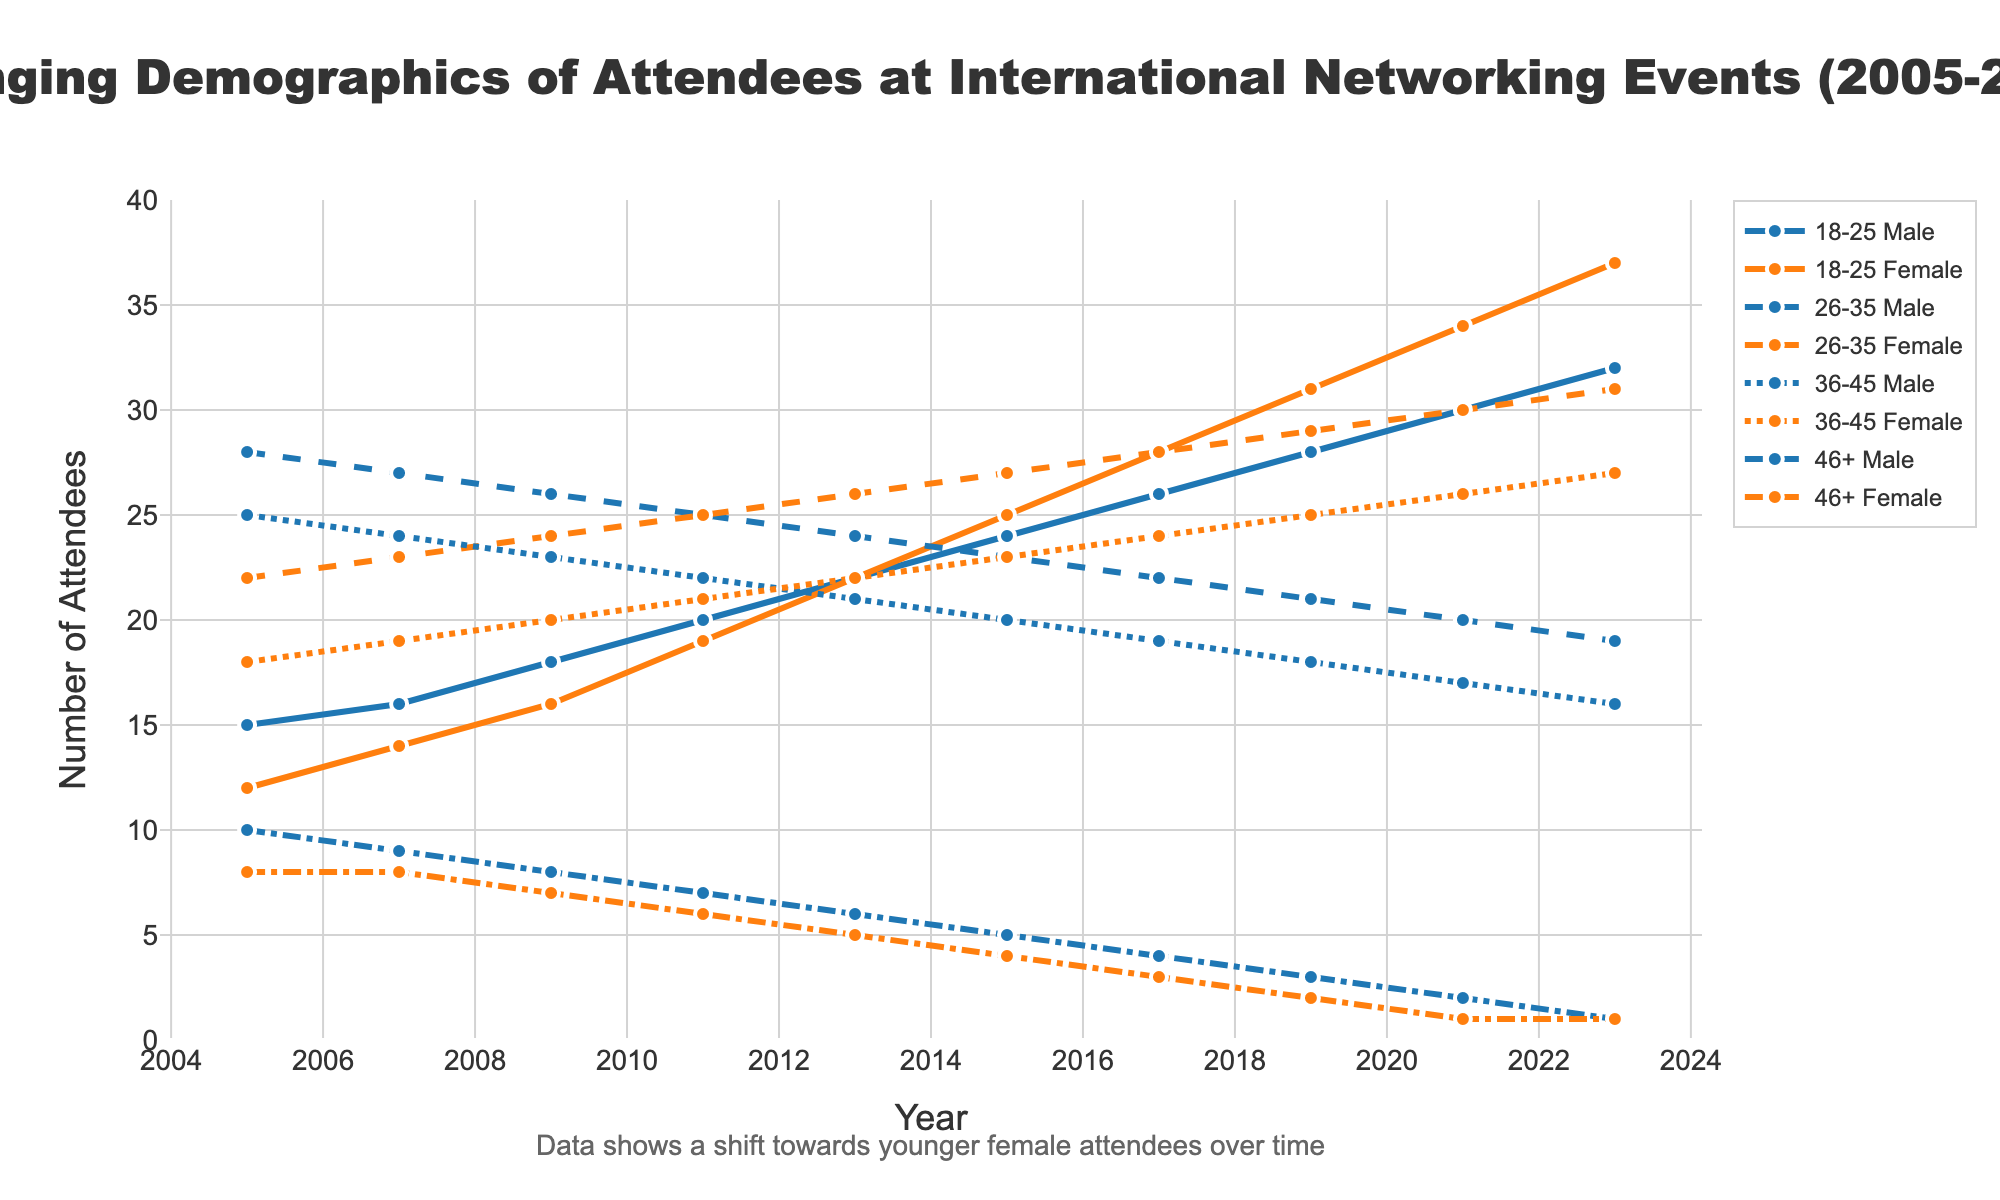Which age group had the greatest increase in female attendees from 2005 to 2023? To find this, compare the number of female attendees in each age group for 2023 with 2005. Calculate the increase for each group: (18-25): 37-12=25, (26-35): 31-22=9, (36-45): 27-18=9, (46+): 1-8=-7. The group 18-25 had the greatest increase.
Answer: 18-25 Between which two consecutive years did the number of 26-35 Male attendees see the largest decrease? Check the number of 26-35 Male attendees for each year and find the differences between consecutive years: (2005-2007): 27-28=-1, (2007-2009): 26-27=-1, (2009-2011): 25-26=-1, (2011-2013): 24-25=-1, (2013-2015): 23-24=-1, (2015-2017): 22-23=-1, (2017-2019): 21-22=-1, (2019-2021): 20-21=-1, (2021-2023): 19-20=-1. Each year shows a decrease of 1, thus any consecutive years can be mentioned.
Answer: 2005-2007 What is the total number of attendees in 2023? Sum the number of all attendees for 2023: 32 (18-25 Male) + 37 (18-25 Female) + 19 (26-35 Male) + 31 (26-35 Female) + 16 (36-45 Male) + 27 (36-45 Female) + 1 (46+ Male) + 1 (46+ Female) = 164.
Answer: 164 In which year did the representation of 36-45 females equal the representation of 36-45 males? Look at the dataset to find where the values for 36-45 females are equal to 36-45 males. In 2011, both 36-45 Male and 36-45 Female have 21 attendees.
Answer: 2011 By looking at the visual, which age group has the most evenly distributed gender representation in 2005? Check the visual lines for 2005; 18-25 males and females are close in number, indicated by the points for each gender being close together for the year 2005.
Answer: 18-25 How does the trend for 46+ Male and Female attendees change over the years? Observe the visual where lines representing 46+ Male and Female consistently decrease over the years, moving towards fewer attendees.
Answer: Decreasing What is the average number of 18-25 Female attendees from 2005 to 2023? Sum the 18-25 Female attendees and divide by the number of years: (12 + 14 + 16 + 19 + 22 + 25 + 28 + 31 + 34 + 37) = 238, 238/10 = 23.8.
Answer: 23.8 